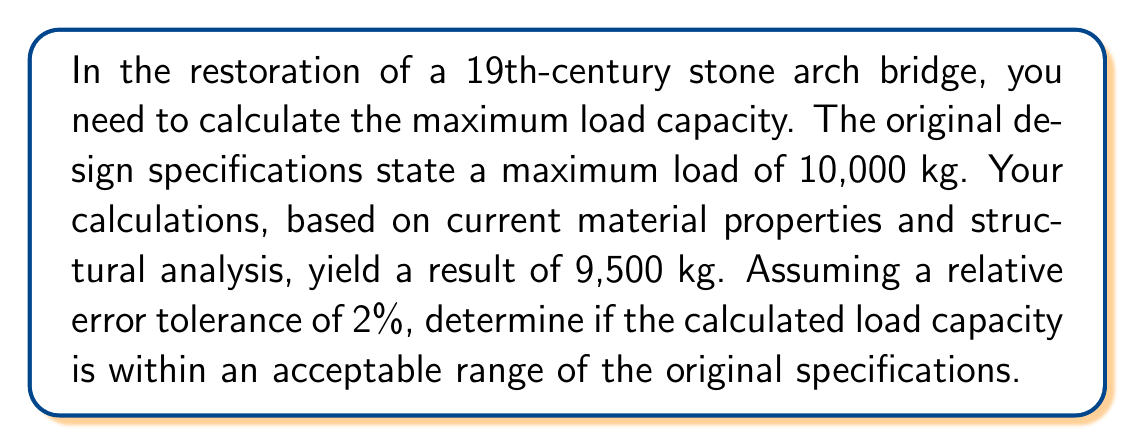Help me with this question. To solve this problem, we need to calculate the relative error and compare it to the given tolerance. Let's follow these steps:

1. Define the variables:
   $x_{true}$ = 10,000 kg (original specification)
   $x_{calculated}$ = 9,500 kg (current calculation)

2. Calculate the absolute error:
   $\text{Absolute Error} = |x_{true} - x_{calculated}|$
   $\text{Absolute Error} = |10,000 - 9,500| = 500$ kg

3. Calculate the relative error:
   $$\text{Relative Error} = \frac{|\text{Absolute Error}|}{|x_{true}|} \times 100\%$$
   $$\text{Relative Error} = \frac{|500|}{|10,000|} \times 100\% = 0.05 \times 100\% = 5\%$$

4. Compare the calculated relative error to the given tolerance:
   Calculated Relative Error: 5%
   Given Tolerance: 2%

5. Since 5% > 2%, the calculated load capacity is not within the acceptable range of the original specifications.
Answer: No, not acceptable. 5% > 2% tolerance. 